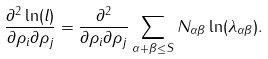Convert formula to latex. <formula><loc_0><loc_0><loc_500><loc_500>\frac { \partial ^ { 2 } \ln ( l ) } { \partial \rho _ { i } \partial \rho _ { j } } = \frac { \partial ^ { 2 } } { \partial \rho _ { i } \partial \rho _ { j } } \sum _ { \alpha + \beta \leq S } N _ { \alpha \beta } \ln ( \lambda _ { \alpha \beta } ) .</formula> 